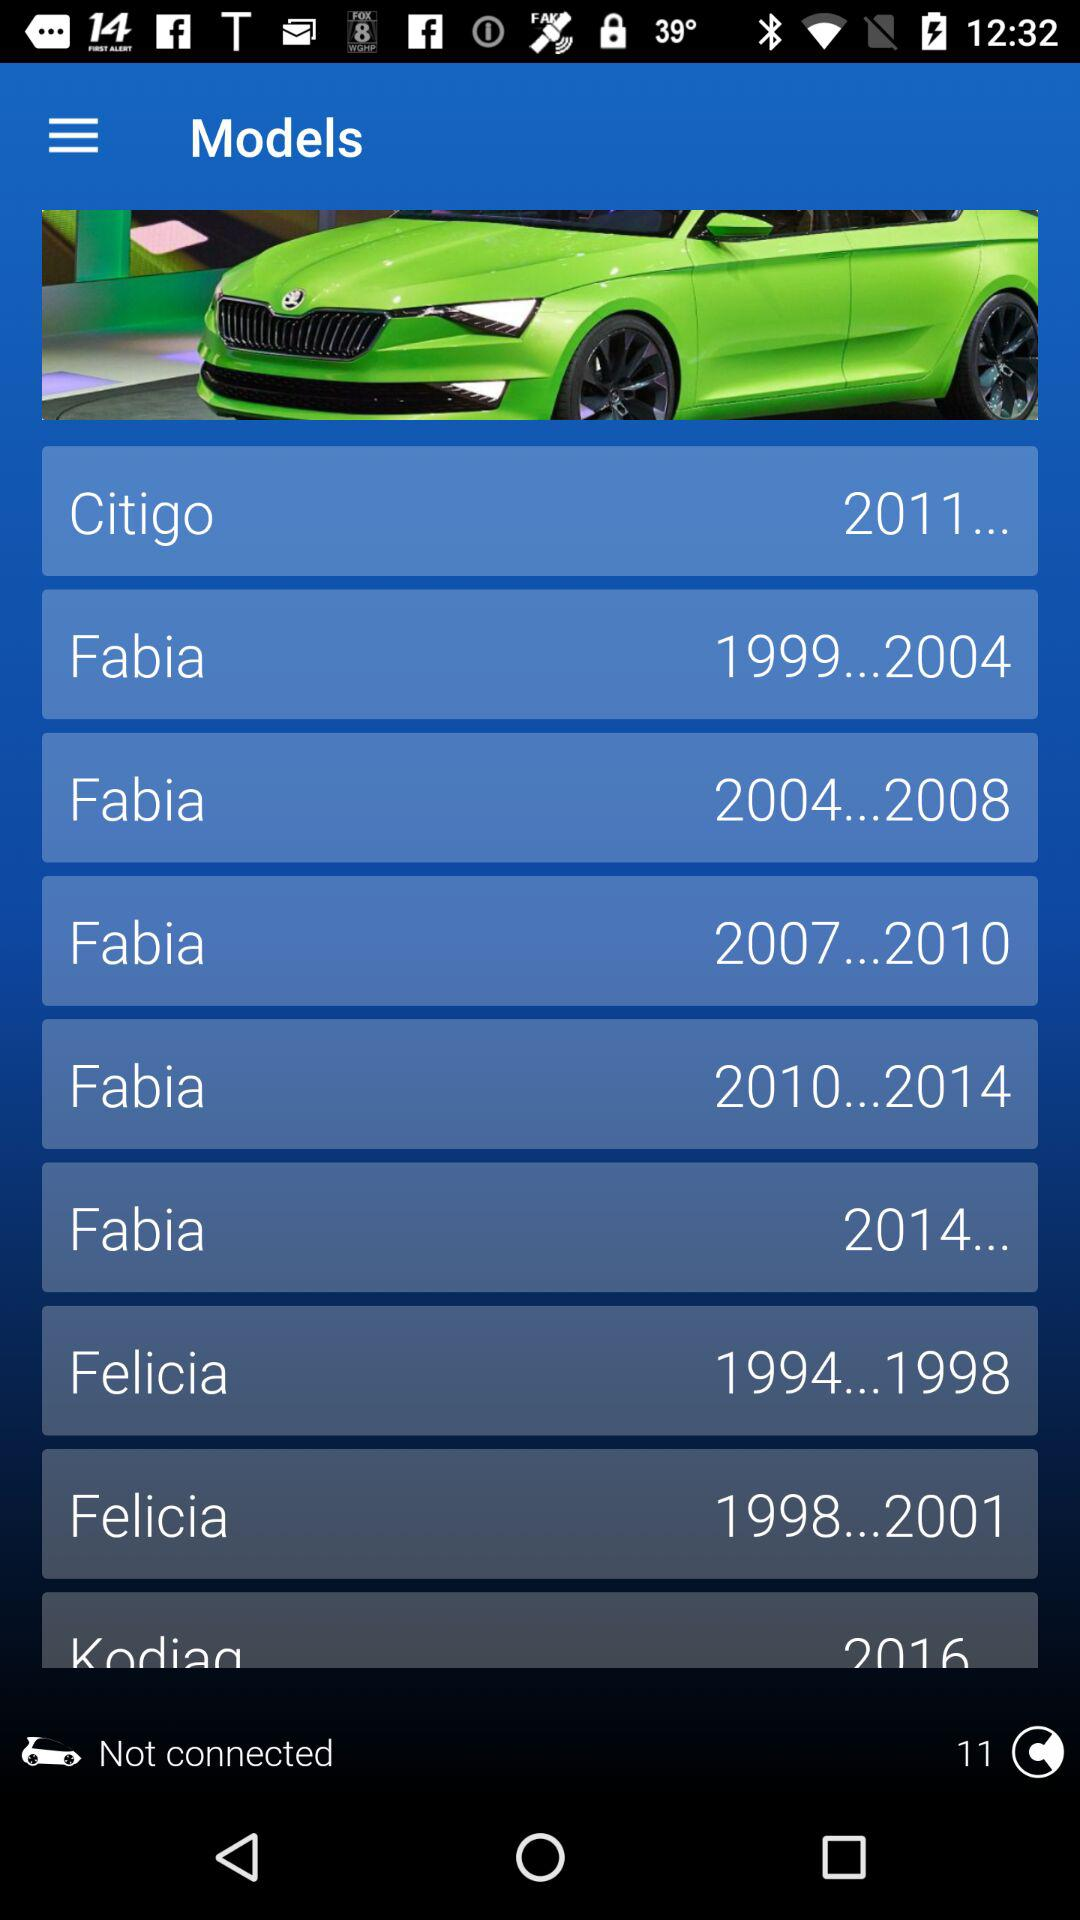What model was manufactured in 2014? The model manufactured in 2014 was the "Fabia". 